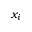Convert formula to latex. <formula><loc_0><loc_0><loc_500><loc_500>x _ { i }</formula> 